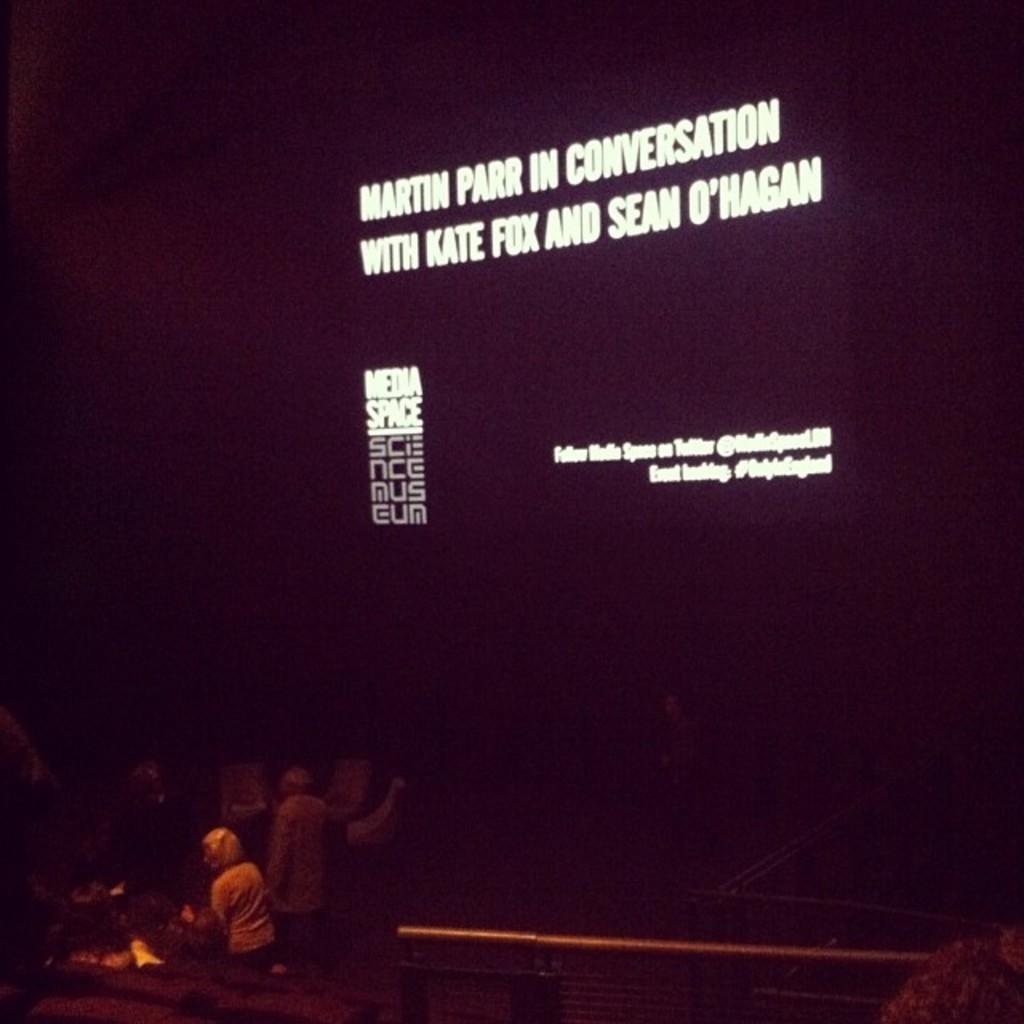What is happening on the stage in the image? There are people on the stage in the image. What can be seen behind the people on the stage? There is a screen behind the people on the stage. What type of trousers are the people on the stage wearing? The provided facts do not mention the type of trousers the people on the stage are wearing, so we cannot answer this question definitively. 